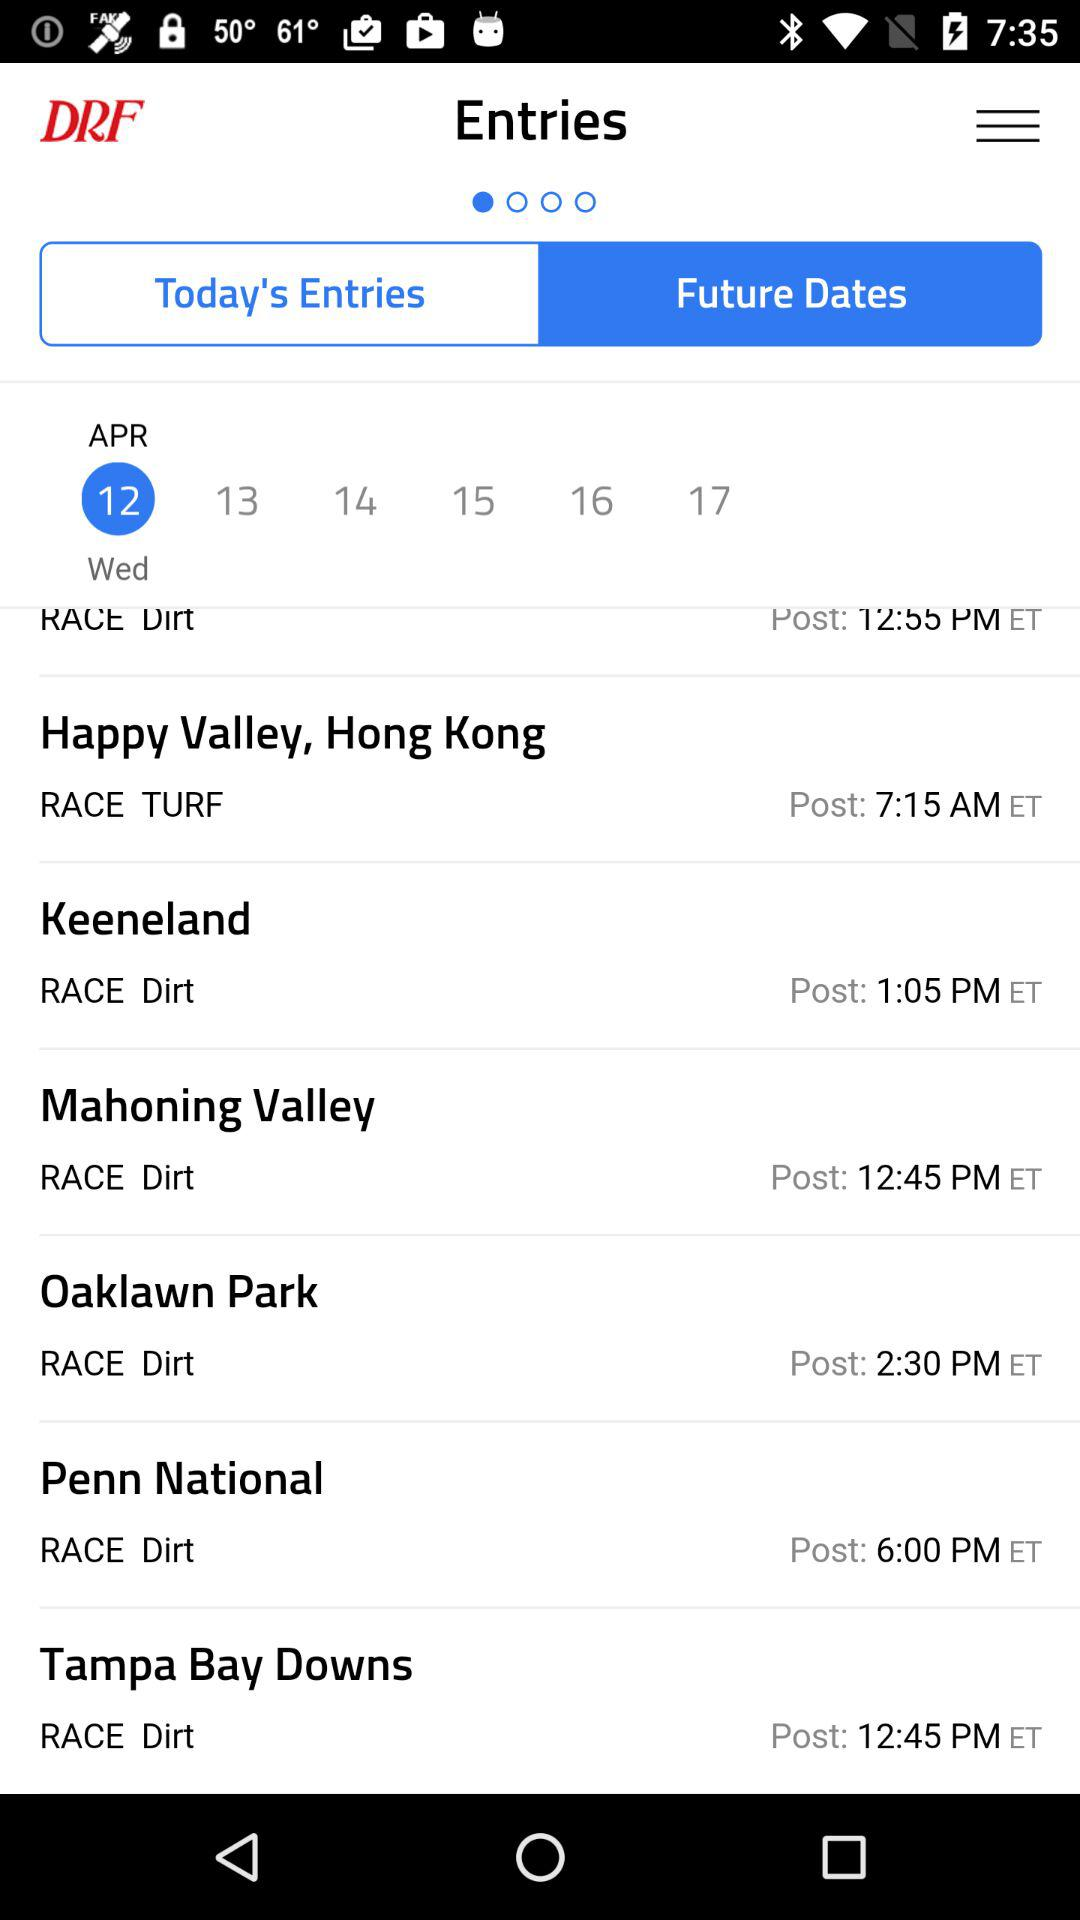What tab is selected in "Entries"? The selected tab is "Future Dates". 